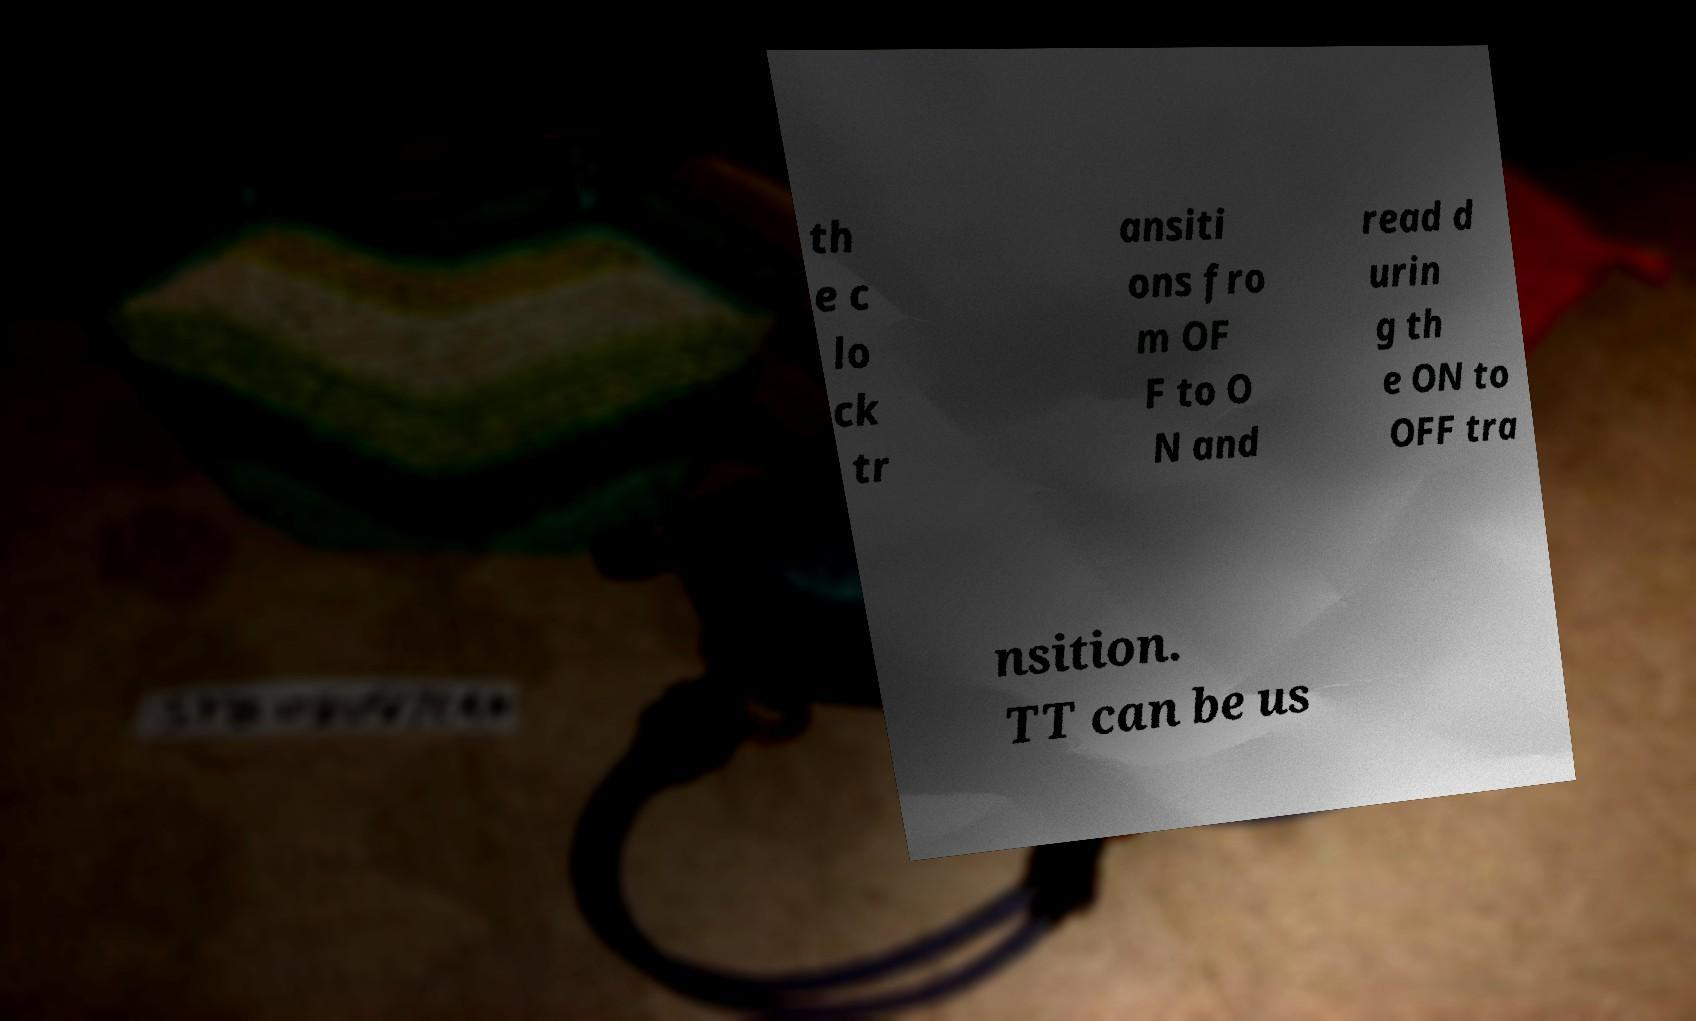Can you accurately transcribe the text from the provided image for me? th e c lo ck tr ansiti ons fro m OF F to O N and read d urin g th e ON to OFF tra nsition. TT can be us 